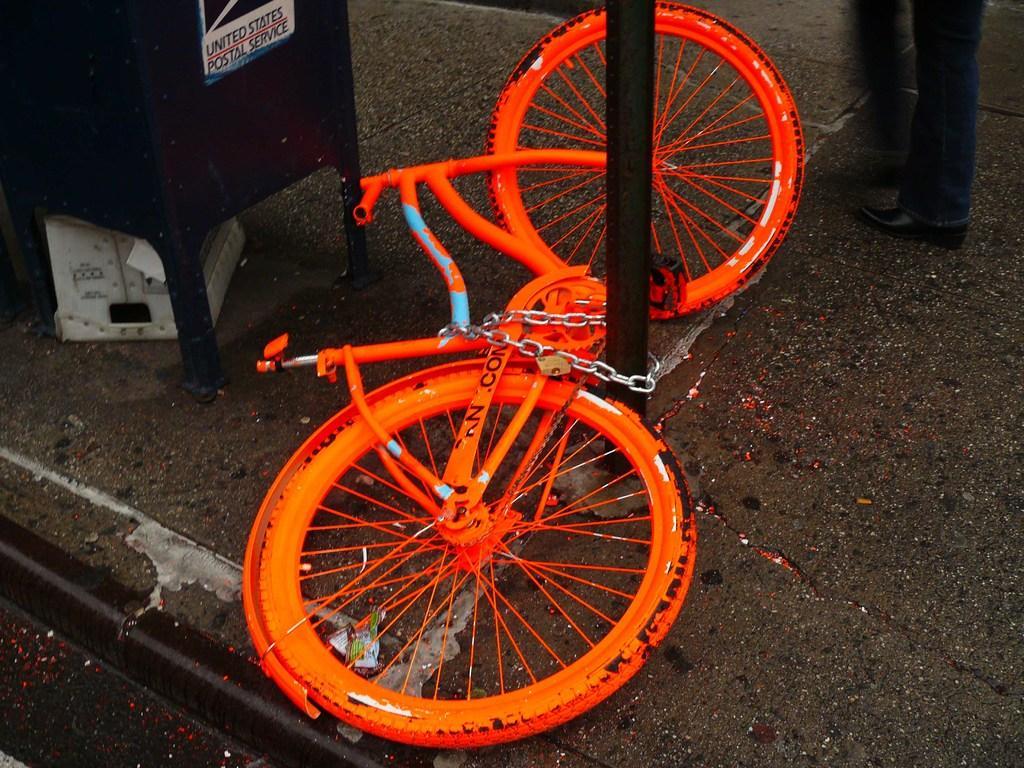How would you summarize this image in a sentence or two? In this picture I can see an orange color bicycle, there is a chain, a pole, there is a person standing and there are some objects. 